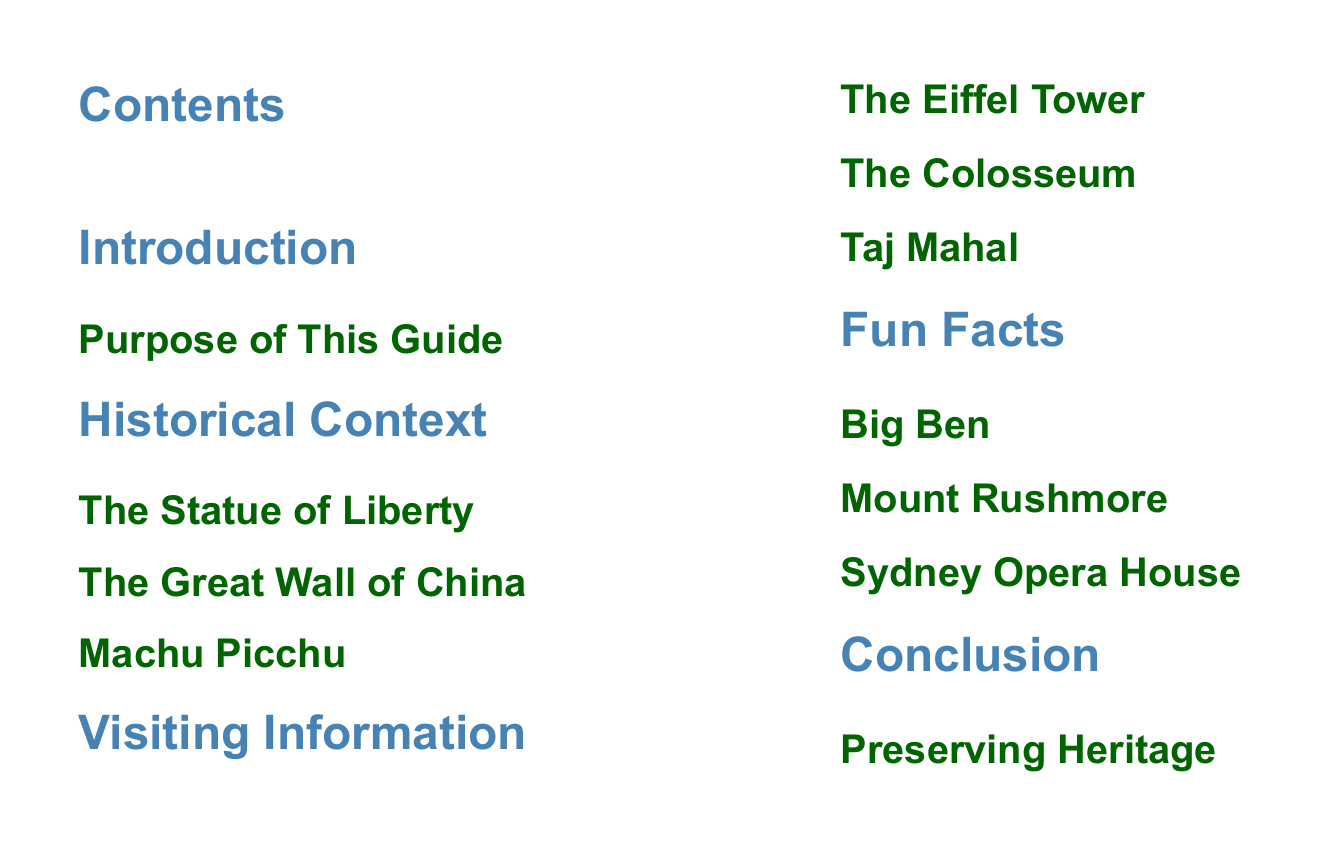What is the purpose of this guide? The purpose of the guide is outlined in the introduction section of the document.
Answer: Purpose of This Guide How many historical landmarks are mentioned? The historical context section lists three landmarks.
Answer: 3 What is the first landmark listed under Visiting Information? The visiting information section presents landmarks, starting with the first one.
Answer: The Eiffel Tower Which landmark is associated with the fun fact section? The fun facts section lists three landmarks, one of which is Big Ben.
Answer: Big Ben What section comes before the conclusion? The document is organized in a clear structure, listing sections in order.
Answer: Fun Facts 